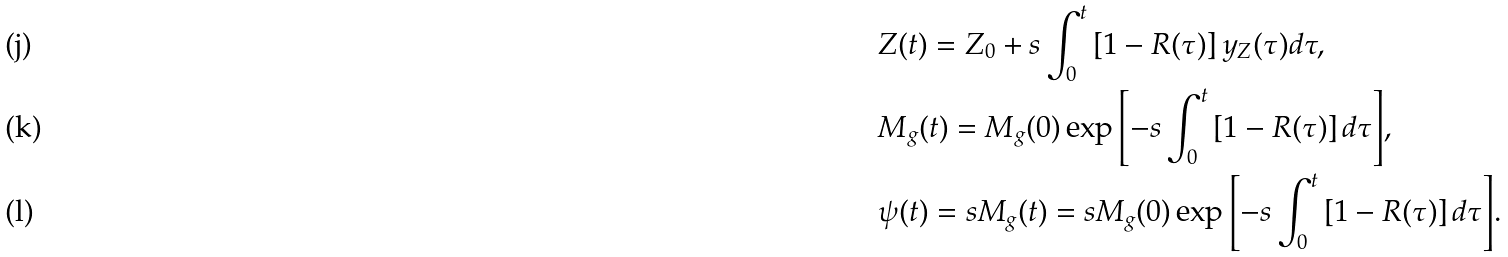<formula> <loc_0><loc_0><loc_500><loc_500>& Z ( t ) = Z _ { 0 } + s \int _ { 0 } ^ { t } \left [ 1 - R ( \tau ) \right ] y _ { Z } ( \tau ) d \tau , \\ & M _ { g } ( t ) = M _ { g } ( 0 ) \exp { \left [ - s \int _ { 0 } ^ { t } \left [ 1 - R ( \tau ) \right ] d \tau \right ] } , \\ & \psi ( t ) = s M _ { g } ( t ) = s M _ { g } ( 0 ) \exp { \left [ - s \int _ { 0 } ^ { t } \left [ 1 - R ( \tau ) \right ] d \tau \right ] } .</formula> 